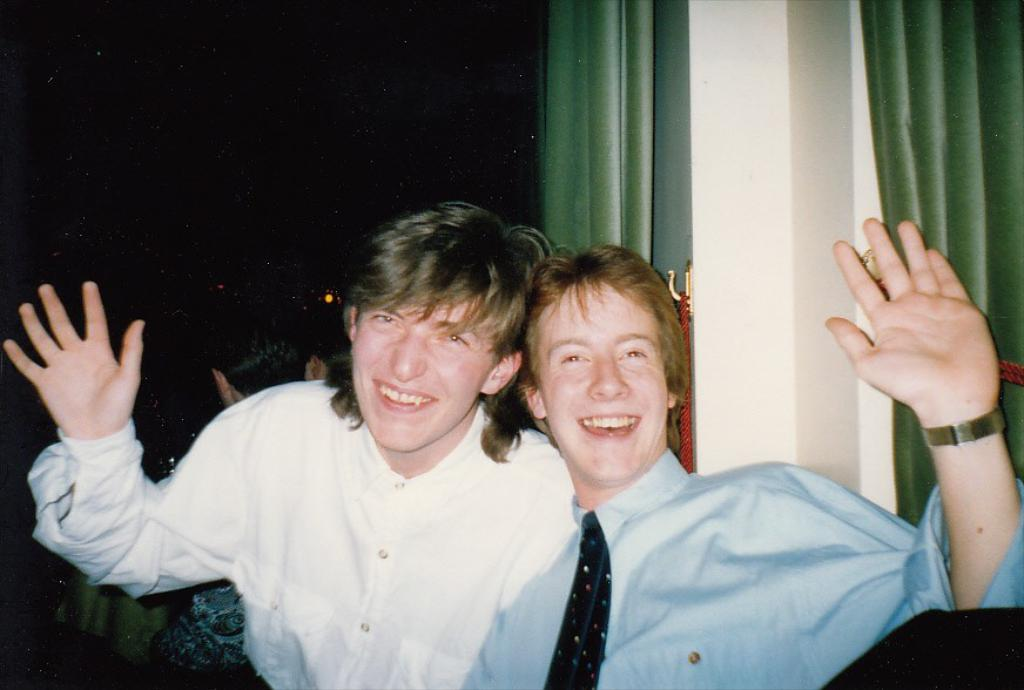How many people are in the image? There are two persons in the image. What is the facial expression of the persons in the image? The persons are smiling. What can be seen in the background of the image? There is a wall and green curtains in the background of the image. Can you describe the person visible in the background? There is a person visible in the background of the image. What is the lighting condition in the image? The background of the image is dark. How many letters are being held by the spiders in the image? There are no spiders or letters present in the image. What type of flag is being waved by the person in the background? There is no flag visible in the image; only a person is present in the background. 